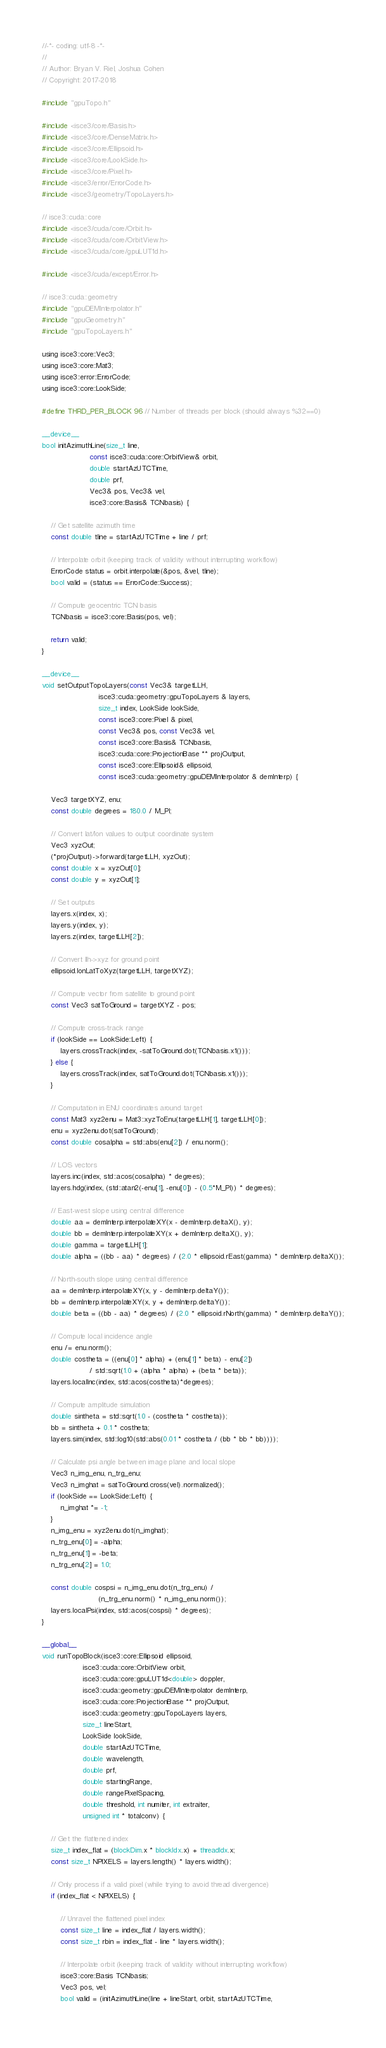Convert code to text. <code><loc_0><loc_0><loc_500><loc_500><_Cuda_>//-*- coding: utf-8 -*-
//
// Author: Bryan V. Riel, Joshua Cohen
// Copyright: 2017-2018

#include "gpuTopo.h"

#include <isce3/core/Basis.h>
#include <isce3/core/DenseMatrix.h>
#include <isce3/core/Ellipsoid.h>
#include <isce3/core/LookSide.h>
#include <isce3/core/Pixel.h>
#include <isce3/error/ErrorCode.h>
#include <isce3/geometry/TopoLayers.h>

// isce3::cuda::core
#include <isce3/cuda/core/Orbit.h>
#include <isce3/cuda/core/OrbitView.h>
#include <isce3/cuda/core/gpuLUT1d.h>

#include <isce3/cuda/except/Error.h>

// isce3::cuda::geometry
#include "gpuDEMInterpolator.h"
#include "gpuGeometry.h"
#include "gpuTopoLayers.h"

using isce3::core::Vec3;
using isce3::core::Mat3;
using isce3::error::ErrorCode;
using isce3::core::LookSide;

#define THRD_PER_BLOCK 96 // Number of threads per block (should always %32==0)

__device__
bool initAzimuthLine(size_t line,
                     const isce3::cuda::core::OrbitView& orbit,
                     double startAzUTCTime,
                     double prf,
                     Vec3& pos, Vec3& vel,
                     isce3::core::Basis& TCNbasis) {

    // Get satellite azimuth time
    const double tline = startAzUTCTime + line / prf;

    // Interpolate orbit (keeping track of validity without interrupting workflow)
    ErrorCode status = orbit.interpolate(&pos, &vel, tline);
    bool valid = (status == ErrorCode::Success);

    // Compute geocentric TCN basis
    TCNbasis = isce3::core::Basis(pos, vel);

    return valid;
}

__device__
void setOutputTopoLayers(const Vec3& targetLLH,
                         isce3::cuda::geometry::gpuTopoLayers & layers,
                         size_t index, LookSide lookSide,
                         const isce3::core::Pixel & pixel,
                         const Vec3& pos, const Vec3& vel,
                         const isce3::core::Basis& TCNbasis,
                         isce3::cuda::core::ProjectionBase ** projOutput,
                         const isce3::core::Ellipsoid& ellipsoid,
                         const isce3::cuda::geometry::gpuDEMInterpolator & demInterp) {

    Vec3 targetXYZ, enu;
    const double degrees = 180.0 / M_PI;

    // Convert lat/lon values to output coordinate system
    Vec3 xyzOut;
    (*projOutput)->forward(targetLLH, xyzOut);
    const double x = xyzOut[0];
    const double y = xyzOut[1];

    // Set outputs
    layers.x(index, x);
    layers.y(index, y);
    layers.z(index, targetLLH[2]);

    // Convert llh->xyz for ground point
    ellipsoid.lonLatToXyz(targetLLH, targetXYZ);

    // Compute vector from satellite to ground point
    const Vec3 satToGround = targetXYZ - pos;

    // Compute cross-track range
    if (lookSide == LookSide::Left) {
        layers.crossTrack(index, -satToGround.dot(TCNbasis.x1()));
    } else {
        layers.crossTrack(index, satToGround.dot(TCNbasis.x1()));
    }

    // Computation in ENU coordinates around target
    const Mat3 xyz2enu = Mat3::xyzToEnu(targetLLH[1], targetLLH[0]);
    enu = xyz2enu.dot(satToGround);
    const double cosalpha = std::abs(enu[2]) / enu.norm();

    // LOS vectors
    layers.inc(index, std::acos(cosalpha) * degrees);
    layers.hdg(index, (std::atan2(-enu[1], -enu[0]) - (0.5*M_PI)) * degrees);

    // East-west slope using central difference
    double aa = demInterp.interpolateXY(x - demInterp.deltaX(), y);
    double bb = demInterp.interpolateXY(x + demInterp.deltaX(), y);
    double gamma = targetLLH[1];
    double alpha = ((bb - aa) * degrees) / (2.0 * ellipsoid.rEast(gamma) * demInterp.deltaX());

    // North-south slope using central difference
    aa = demInterp.interpolateXY(x, y - demInterp.deltaY());
    bb = demInterp.interpolateXY(x, y + demInterp.deltaY());
    double beta = ((bb - aa) * degrees) / (2.0 * ellipsoid.rNorth(gamma) * demInterp.deltaY());

    // Compute local incidence angle
    enu /= enu.norm();
    double costheta = ((enu[0] * alpha) + (enu[1] * beta) - enu[2])
                     / std::sqrt(1.0 + (alpha * alpha) + (beta * beta));
    layers.localInc(index, std::acos(costheta)*degrees);

    // Compute amplitude simulation
    double sintheta = std::sqrt(1.0 - (costheta * costheta));
    bb = sintheta + 0.1 * costheta;
    layers.sim(index, std::log10(std::abs(0.01 * costheta / (bb * bb * bb))));

    // Calculate psi angle between image plane and local slope
    Vec3 n_img_enu, n_trg_enu;
    Vec3 n_imghat = satToGround.cross(vel).normalized();
    if (lookSide == LookSide::Left) {
        n_imghat *= -1;
    }
    n_img_enu = xyz2enu.dot(n_imghat);
    n_trg_enu[0] = -alpha;
    n_trg_enu[1] = -beta;
    n_trg_enu[2] = 1.0;

    const double cospsi = n_img_enu.dot(n_trg_enu) /
                         (n_trg_enu.norm() * n_img_enu.norm());
    layers.localPsi(index, std::acos(cospsi) * degrees);
}

__global__
void runTopoBlock(isce3::core::Ellipsoid ellipsoid,
                  isce3::cuda::core::OrbitView orbit,
                  isce3::cuda::core::gpuLUT1d<double> doppler,
                  isce3::cuda::geometry::gpuDEMInterpolator demInterp,
                  isce3::cuda::core::ProjectionBase ** projOutput,
                  isce3::cuda::geometry::gpuTopoLayers layers,
                  size_t lineStart,
                  LookSide lookSide,
                  double startAzUTCTime,
                  double wavelength,
                  double prf,
                  double startingRange,
                  double rangePixelSpacing,
                  double threshold, int numiter, int extraiter,
                  unsigned int * totalconv) {

    // Get the flattened index
    size_t index_flat = (blockDim.x * blockIdx.x) + threadIdx.x;
    const size_t NPIXELS = layers.length() * layers.width();

    // Only process if a valid pixel (while trying to avoid thread divergence)
    if (index_flat < NPIXELS) {

        // Unravel the flattened pixel index
        const size_t line = index_flat / layers.width();
        const size_t rbin = index_flat - line * layers.width();

        // Interpolate orbit (keeping track of validity without interrupting workflow)
        isce3::core::Basis TCNbasis;
        Vec3 pos, vel;
        bool valid = (initAzimuthLine(line + lineStart, orbit, startAzUTCTime,</code> 